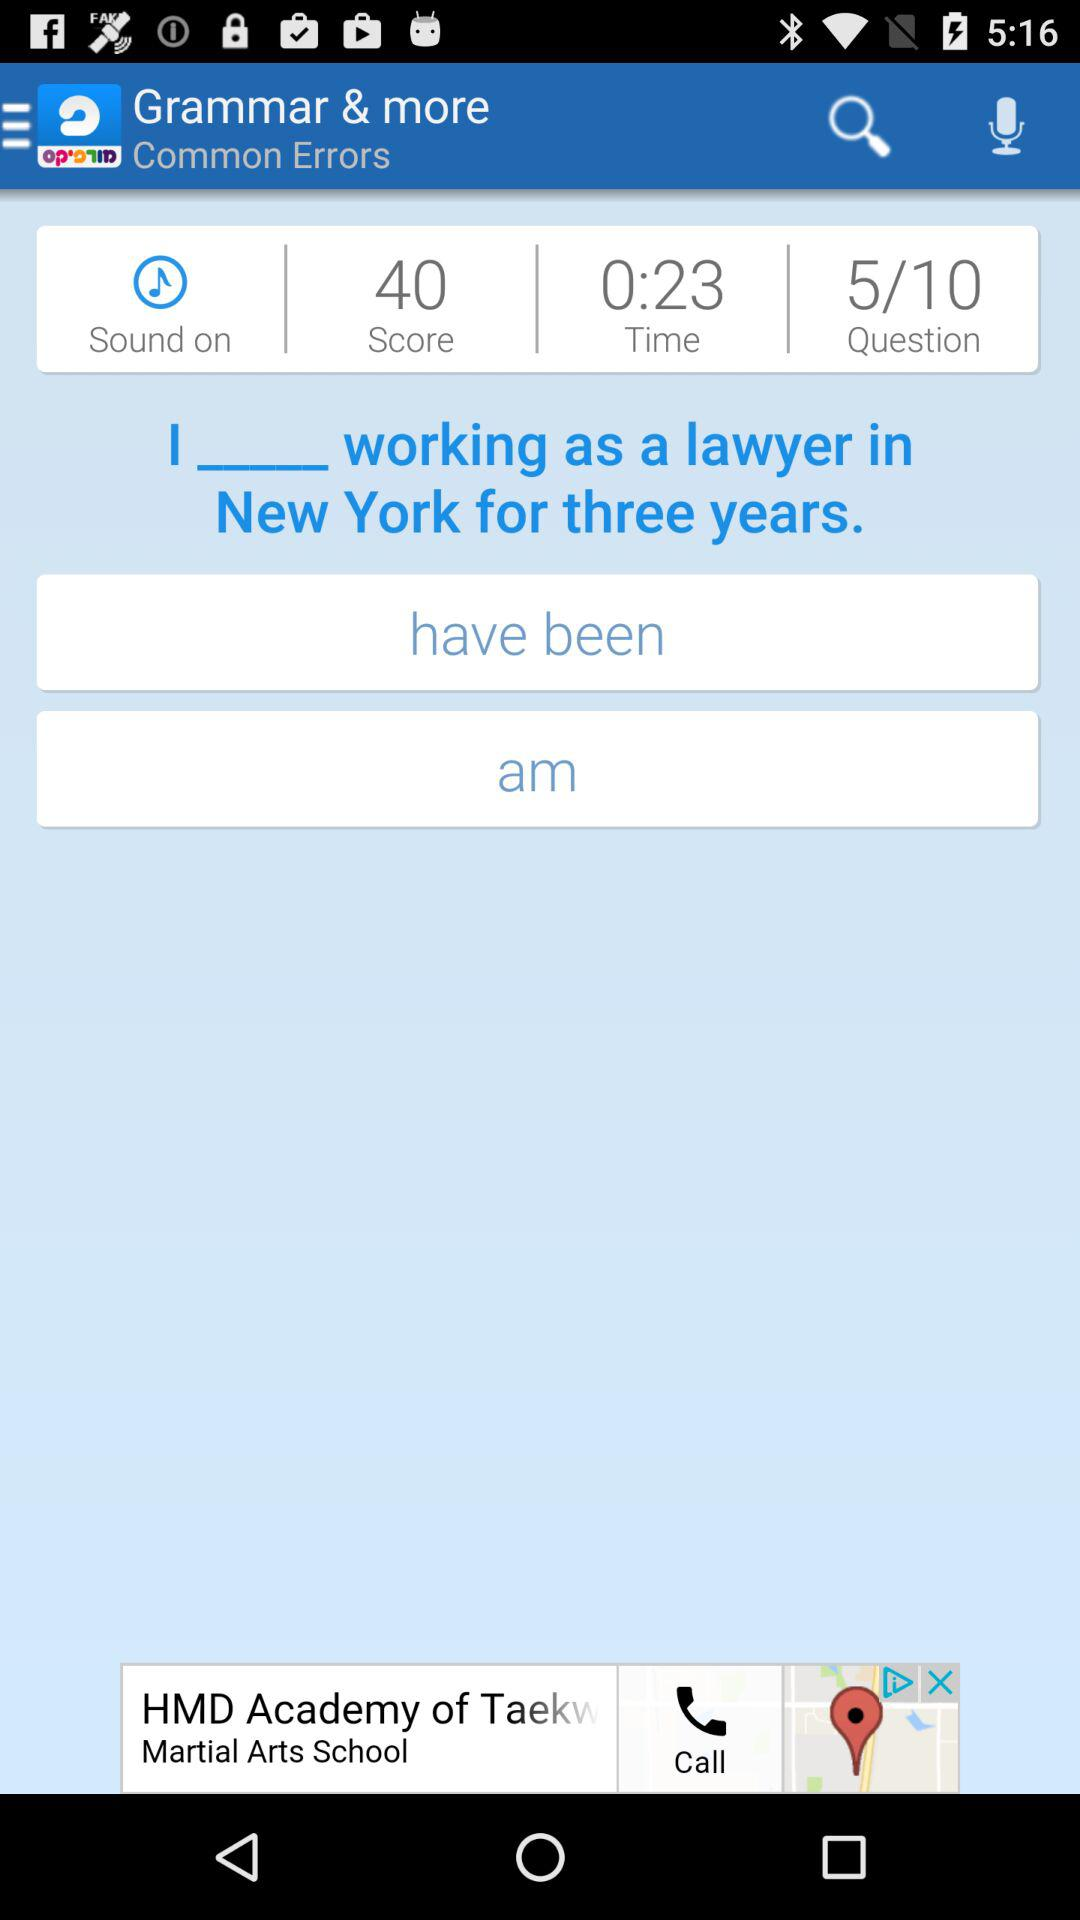What is the shown time? The time is 23 seconds. 